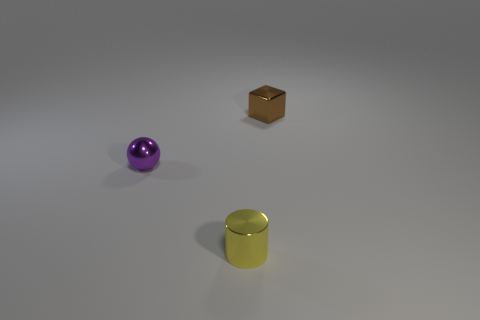Add 3 purple balls. How many objects exist? 6 Subtract all cylinders. How many objects are left? 2 Add 2 big green cylinders. How many big green cylinders exist? 2 Subtract 0 blue cubes. How many objects are left? 3 Subtract all brown blocks. Subtract all purple objects. How many objects are left? 1 Add 3 metallic cubes. How many metallic cubes are left? 4 